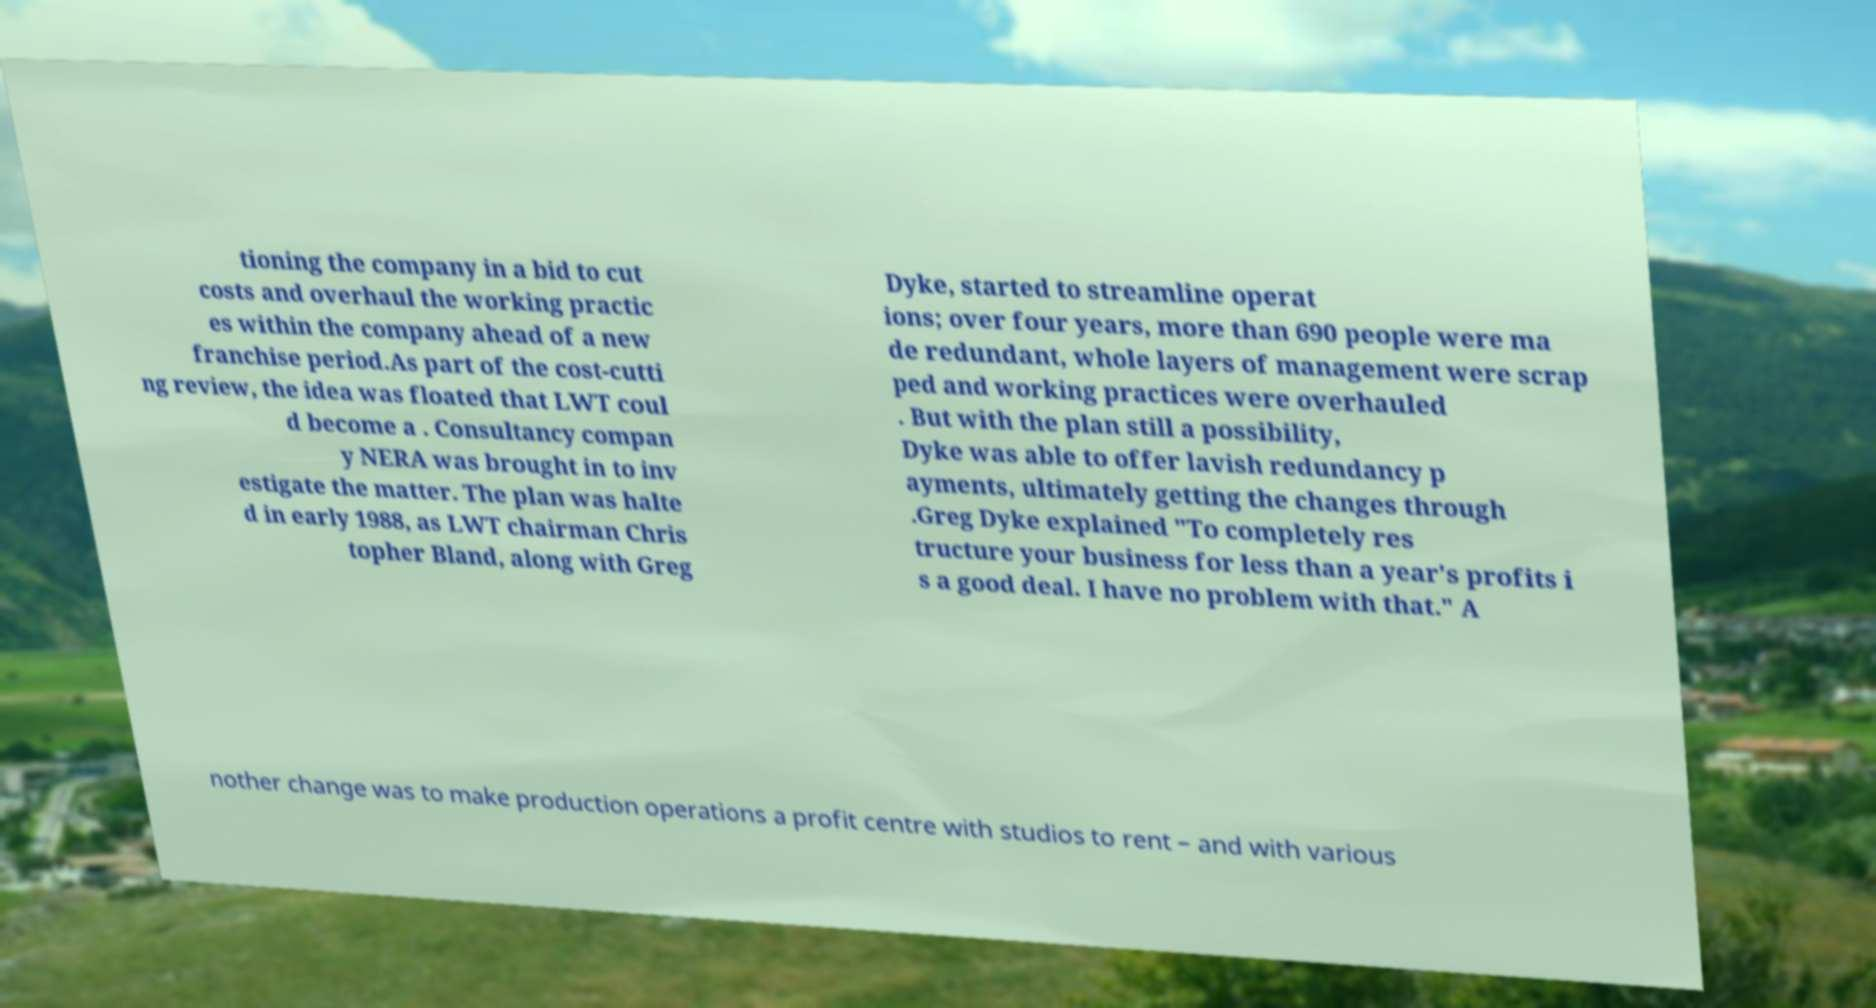Could you assist in decoding the text presented in this image and type it out clearly? tioning the company in a bid to cut costs and overhaul the working practic es within the company ahead of a new franchise period.As part of the cost-cutti ng review, the idea was floated that LWT coul d become a . Consultancy compan y NERA was brought in to inv estigate the matter. The plan was halte d in early 1988, as LWT chairman Chris topher Bland, along with Greg Dyke, started to streamline operat ions; over four years, more than 690 people were ma de redundant, whole layers of management were scrap ped and working practices were overhauled . But with the plan still a possibility, Dyke was able to offer lavish redundancy p ayments, ultimately getting the changes through .Greg Dyke explained "To completely res tructure your business for less than a year's profits i s a good deal. I have no problem with that." A nother change was to make production operations a profit centre with studios to rent – and with various 